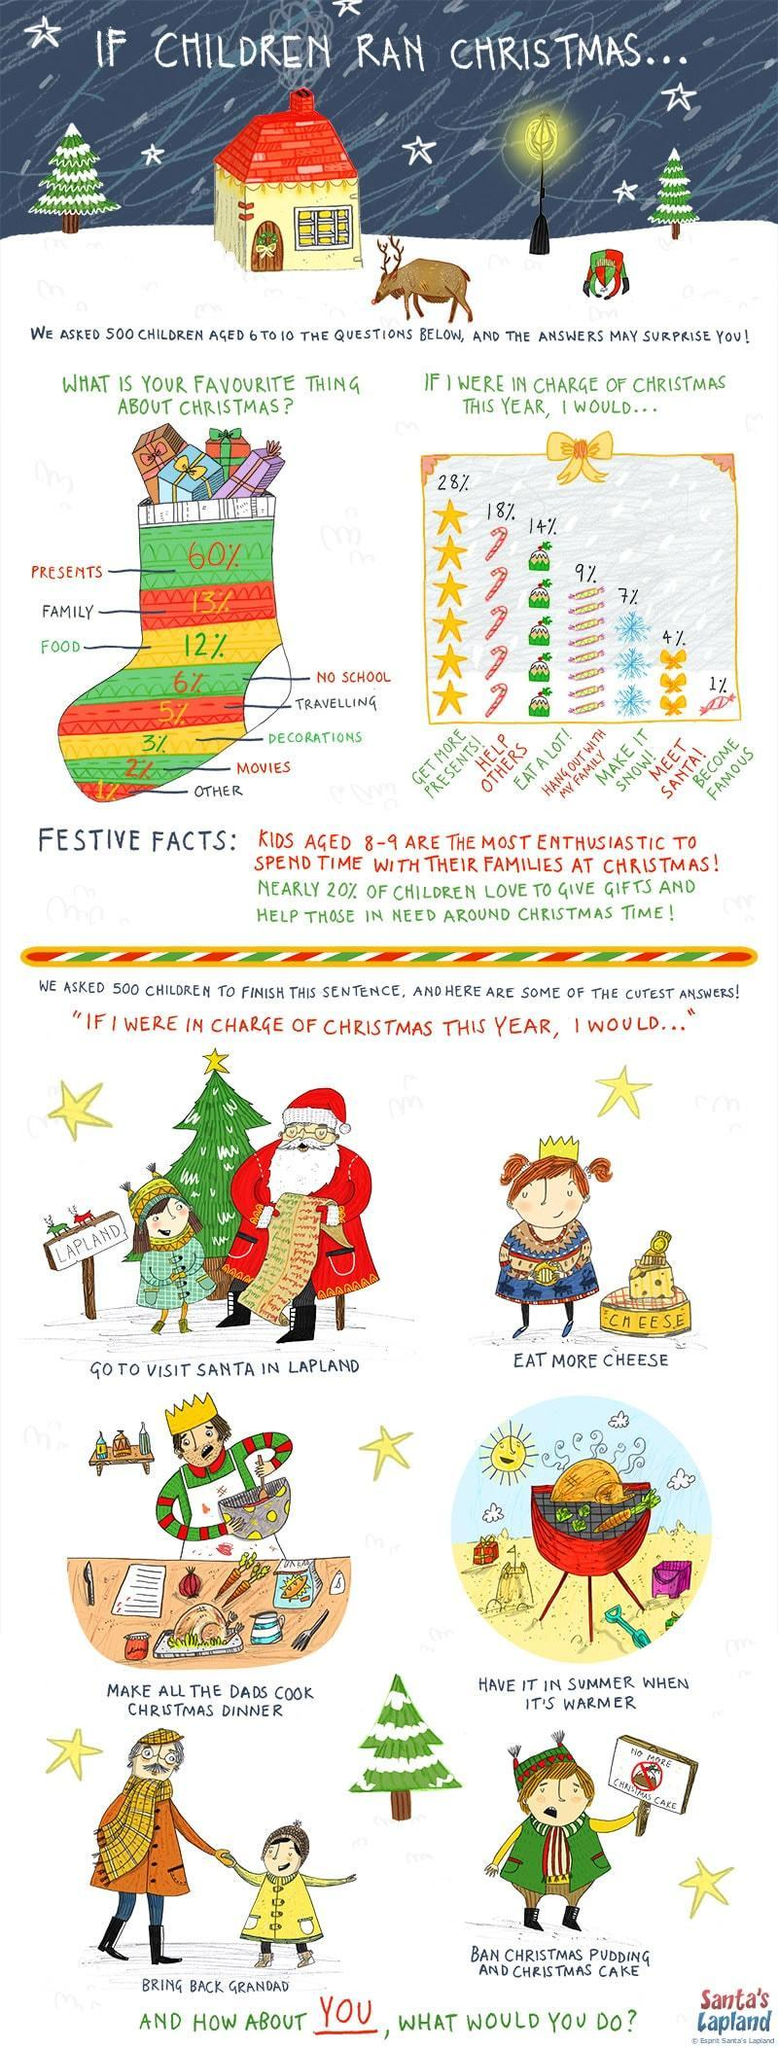What is percentage difference between children who loved receiving presents and children who wanted to help others?
Answer the question with a short phrase. 10% What percentage of children wanted to spend time with their family for Christmas? 9% Which were the top three things children loved about Christmas? Presents, Family, Food 